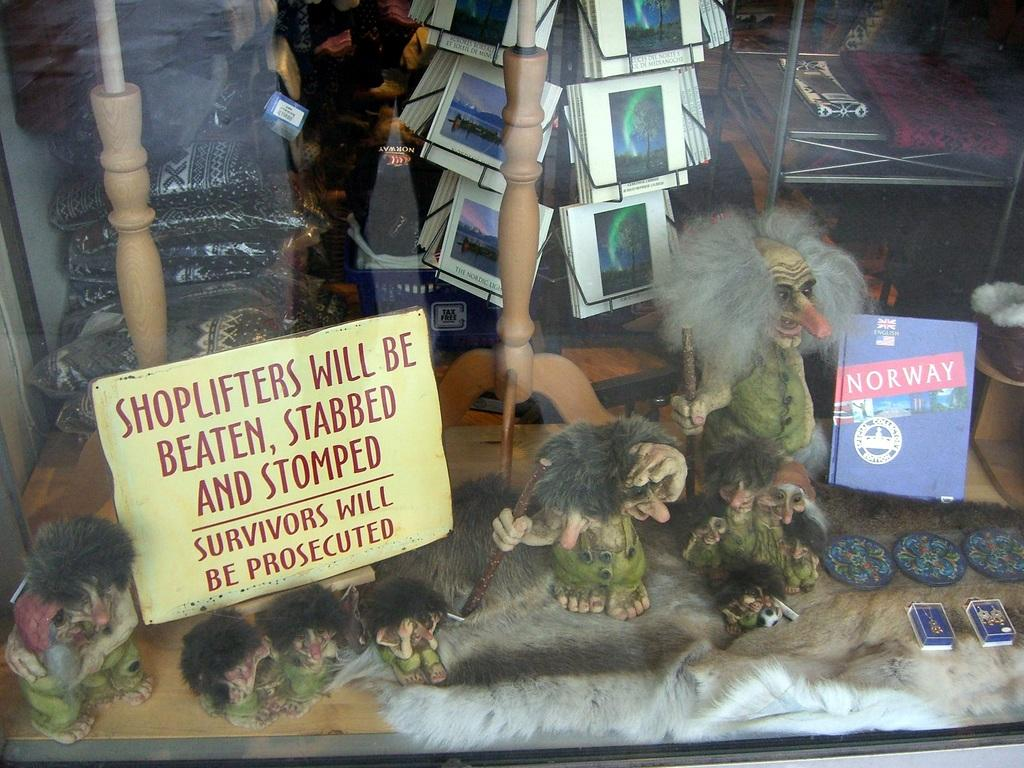<image>
Offer a succinct explanation of the picture presented. Anitque store that has a sign saying Shoplifters will be beaten, stabbed, and stomped. 